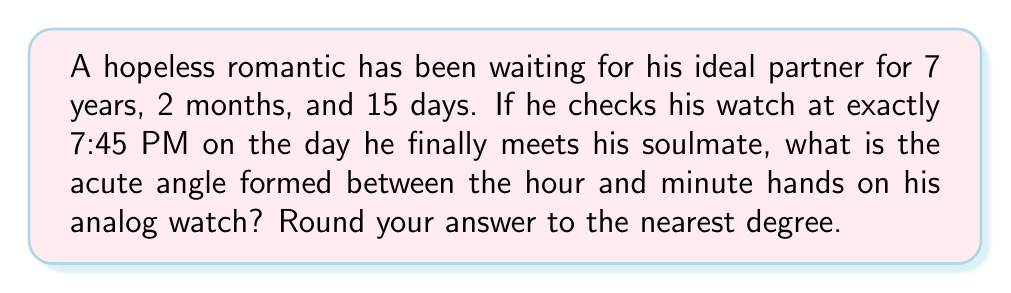Help me with this question. Let's approach this step-by-step:

1) First, we need to understand how the clock hands move:
   - The hour hand makes a complete 360° rotation in 12 hours, so it moves at a rate of 360° ÷ 12 = 30° per hour, or 0.5° per minute.
   - The minute hand makes a complete 360° rotation in 60 minutes, so it moves at a rate of 360° ÷ 60 = 6° per minute.

2) At 7:45 PM:
   - The minute hand will have moved 45 * 6° = 270° from the 12 o'clock position.
   - The hour hand will have moved from the 7 o'clock position (210°) plus an additional amount for the 45 minutes:
     $$210° + (45 * 0.5°) = 210° + 22.5° = 232.5°$$

3) The angle between the hands is the absolute difference between these angles:
   $$|270° - 232.5°| = 37.5°$$

4) Since we're asked for the acute angle, and 37.5° is already acute, this is our answer.

5) Rounding to the nearest degree gives us 38°.

[asy]
import geometry;

size(200);
draw(circle((0,0),1));
for(int i=0; i<12; ++i) {
  dot(dir(30*i));
}
draw((0,0)--dir(232.5), arrow=Arrow(TeXHead));
draw((0,0)--dir(270), arrow=Arrow(TeXHead));
label("7", dir(210), SW);
label("9", dir(270), S);
draw(arc((0,0),0.3,232.5,270), blue);
label("37.5°", (0.2,0.1), blue);
[/asy]
Answer: 38° 